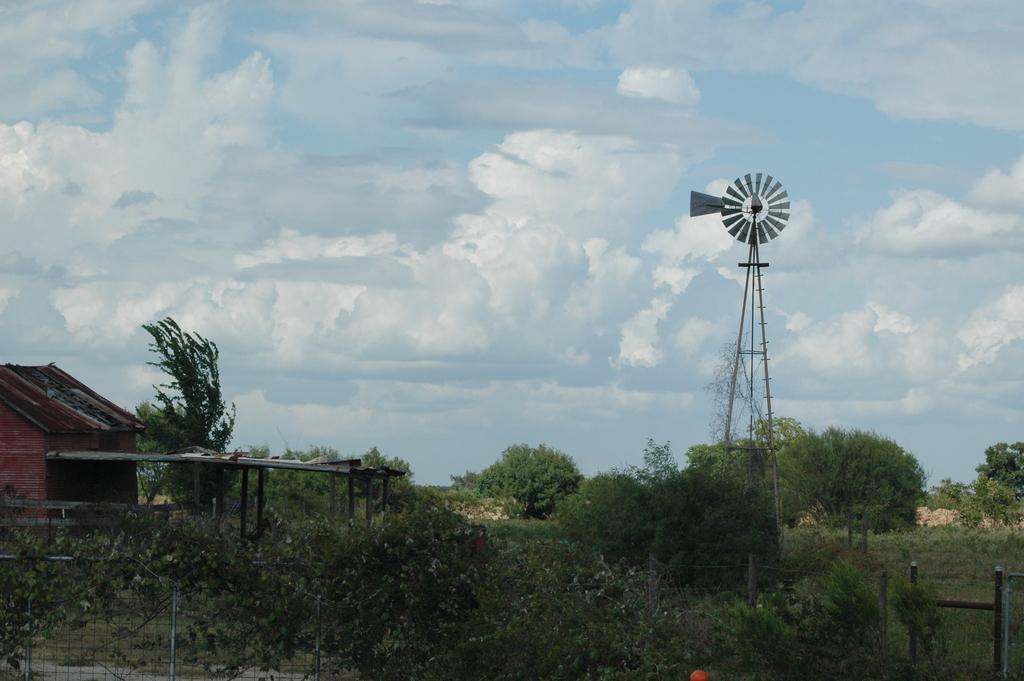What structure is located on the left side of the image? There is a shed on the left side of the image. What can be seen at the bottom of the image? There is a fence at the bottom of the image. What type of vegetation is in the background of the image? There are trees in the background of the image. What is located in the background of the image besides trees? There is a windmill in the background of the image. What is visible at the top of the image? The sky is visible at the top of the image. How many copies of the trees are present in the image? There is no concept of "copy" in the image; the trees are real and not duplicated. Can you describe the fight between the windmill and the fence in the image? There is no fight between the windmill and the fence in the image; they are separate structures that do not interact with each other. 